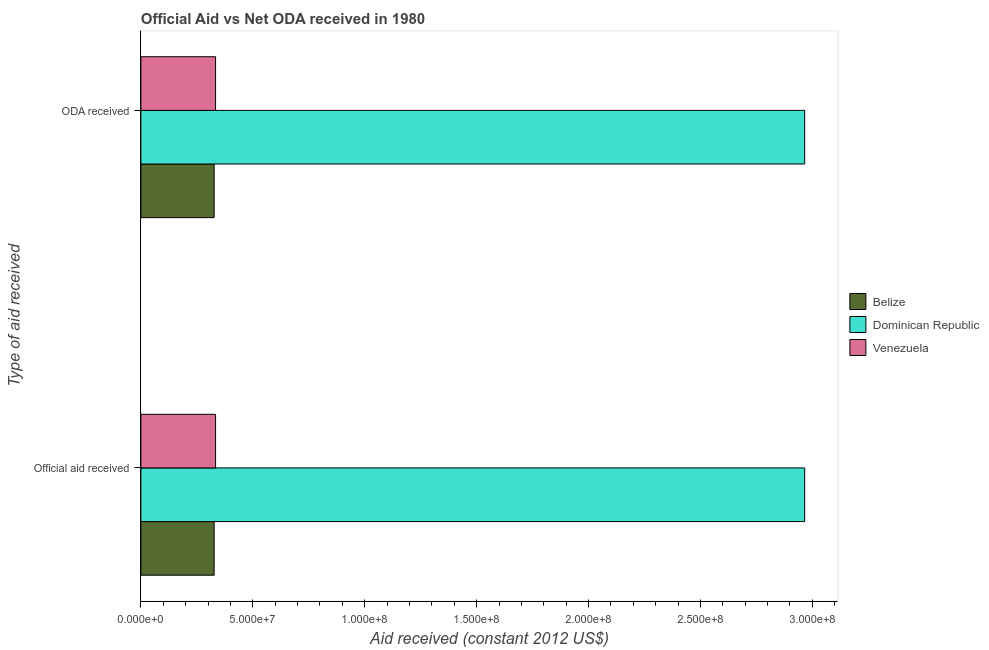How many different coloured bars are there?
Provide a succinct answer. 3. Are the number of bars on each tick of the Y-axis equal?
Your answer should be compact. Yes. How many bars are there on the 2nd tick from the top?
Provide a succinct answer. 3. What is the label of the 2nd group of bars from the top?
Make the answer very short. Official aid received. What is the oda received in Belize?
Provide a short and direct response. 3.27e+07. Across all countries, what is the maximum official aid received?
Ensure brevity in your answer.  2.97e+08. Across all countries, what is the minimum official aid received?
Ensure brevity in your answer.  3.27e+07. In which country was the official aid received maximum?
Provide a short and direct response. Dominican Republic. In which country was the official aid received minimum?
Provide a short and direct response. Belize. What is the total oda received in the graph?
Your response must be concise. 3.63e+08. What is the difference between the official aid received in Belize and that in Dominican Republic?
Your answer should be very brief. -2.64e+08. What is the difference between the official aid received in Venezuela and the oda received in Dominican Republic?
Make the answer very short. -2.63e+08. What is the average oda received per country?
Offer a very short reply. 1.21e+08. What is the difference between the official aid received and oda received in Venezuela?
Ensure brevity in your answer.  0. In how many countries, is the oda received greater than 300000000 US$?
Provide a succinct answer. 0. What is the ratio of the official aid received in Dominican Republic to that in Belize?
Your answer should be very brief. 9.06. What does the 3rd bar from the top in ODA received represents?
Provide a short and direct response. Belize. What does the 3rd bar from the bottom in Official aid received represents?
Your response must be concise. Venezuela. What is the difference between two consecutive major ticks on the X-axis?
Your answer should be very brief. 5.00e+07. Does the graph contain any zero values?
Provide a short and direct response. No. Does the graph contain grids?
Provide a succinct answer. No. Where does the legend appear in the graph?
Give a very brief answer. Center right. How are the legend labels stacked?
Provide a short and direct response. Vertical. What is the title of the graph?
Keep it short and to the point. Official Aid vs Net ODA received in 1980 . What is the label or title of the X-axis?
Provide a short and direct response. Aid received (constant 2012 US$). What is the label or title of the Y-axis?
Ensure brevity in your answer.  Type of aid received. What is the Aid received (constant 2012 US$) of Belize in Official aid received?
Your answer should be compact. 3.27e+07. What is the Aid received (constant 2012 US$) of Dominican Republic in Official aid received?
Make the answer very short. 2.97e+08. What is the Aid received (constant 2012 US$) of Venezuela in Official aid received?
Your answer should be very brief. 3.34e+07. What is the Aid received (constant 2012 US$) in Belize in ODA received?
Your response must be concise. 3.27e+07. What is the Aid received (constant 2012 US$) of Dominican Republic in ODA received?
Provide a succinct answer. 2.97e+08. What is the Aid received (constant 2012 US$) of Venezuela in ODA received?
Provide a short and direct response. 3.34e+07. Across all Type of aid received, what is the maximum Aid received (constant 2012 US$) of Belize?
Your response must be concise. 3.27e+07. Across all Type of aid received, what is the maximum Aid received (constant 2012 US$) in Dominican Republic?
Ensure brevity in your answer.  2.97e+08. Across all Type of aid received, what is the maximum Aid received (constant 2012 US$) in Venezuela?
Your answer should be very brief. 3.34e+07. Across all Type of aid received, what is the minimum Aid received (constant 2012 US$) of Belize?
Ensure brevity in your answer.  3.27e+07. Across all Type of aid received, what is the minimum Aid received (constant 2012 US$) of Dominican Republic?
Provide a succinct answer. 2.97e+08. Across all Type of aid received, what is the minimum Aid received (constant 2012 US$) of Venezuela?
Provide a short and direct response. 3.34e+07. What is the total Aid received (constant 2012 US$) in Belize in the graph?
Provide a succinct answer. 6.54e+07. What is the total Aid received (constant 2012 US$) of Dominican Republic in the graph?
Keep it short and to the point. 5.93e+08. What is the total Aid received (constant 2012 US$) in Venezuela in the graph?
Your response must be concise. 6.67e+07. What is the difference between the Aid received (constant 2012 US$) in Dominican Republic in Official aid received and that in ODA received?
Your response must be concise. 0. What is the difference between the Aid received (constant 2012 US$) in Venezuela in Official aid received and that in ODA received?
Make the answer very short. 0. What is the difference between the Aid received (constant 2012 US$) in Belize in Official aid received and the Aid received (constant 2012 US$) in Dominican Republic in ODA received?
Keep it short and to the point. -2.64e+08. What is the difference between the Aid received (constant 2012 US$) in Belize in Official aid received and the Aid received (constant 2012 US$) in Venezuela in ODA received?
Offer a very short reply. -6.50e+05. What is the difference between the Aid received (constant 2012 US$) of Dominican Republic in Official aid received and the Aid received (constant 2012 US$) of Venezuela in ODA received?
Make the answer very short. 2.63e+08. What is the average Aid received (constant 2012 US$) in Belize per Type of aid received?
Offer a terse response. 3.27e+07. What is the average Aid received (constant 2012 US$) in Dominican Republic per Type of aid received?
Provide a succinct answer. 2.97e+08. What is the average Aid received (constant 2012 US$) in Venezuela per Type of aid received?
Offer a very short reply. 3.34e+07. What is the difference between the Aid received (constant 2012 US$) of Belize and Aid received (constant 2012 US$) of Dominican Republic in Official aid received?
Your answer should be compact. -2.64e+08. What is the difference between the Aid received (constant 2012 US$) in Belize and Aid received (constant 2012 US$) in Venezuela in Official aid received?
Keep it short and to the point. -6.50e+05. What is the difference between the Aid received (constant 2012 US$) of Dominican Republic and Aid received (constant 2012 US$) of Venezuela in Official aid received?
Your answer should be very brief. 2.63e+08. What is the difference between the Aid received (constant 2012 US$) in Belize and Aid received (constant 2012 US$) in Dominican Republic in ODA received?
Provide a succinct answer. -2.64e+08. What is the difference between the Aid received (constant 2012 US$) in Belize and Aid received (constant 2012 US$) in Venezuela in ODA received?
Your response must be concise. -6.50e+05. What is the difference between the Aid received (constant 2012 US$) of Dominican Republic and Aid received (constant 2012 US$) of Venezuela in ODA received?
Give a very brief answer. 2.63e+08. What is the ratio of the Aid received (constant 2012 US$) in Belize in Official aid received to that in ODA received?
Give a very brief answer. 1. What is the ratio of the Aid received (constant 2012 US$) in Dominican Republic in Official aid received to that in ODA received?
Offer a very short reply. 1. What is the ratio of the Aid received (constant 2012 US$) in Venezuela in Official aid received to that in ODA received?
Your response must be concise. 1. What is the difference between the highest and the second highest Aid received (constant 2012 US$) of Belize?
Keep it short and to the point. 0. What is the difference between the highest and the second highest Aid received (constant 2012 US$) in Venezuela?
Provide a short and direct response. 0. What is the difference between the highest and the lowest Aid received (constant 2012 US$) of Dominican Republic?
Offer a very short reply. 0. 